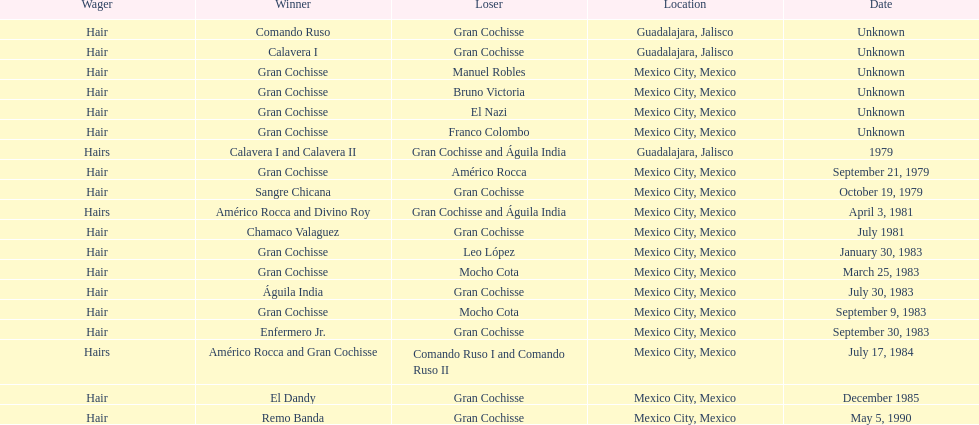How often has gran cochisse emerged as a winner? 9. 